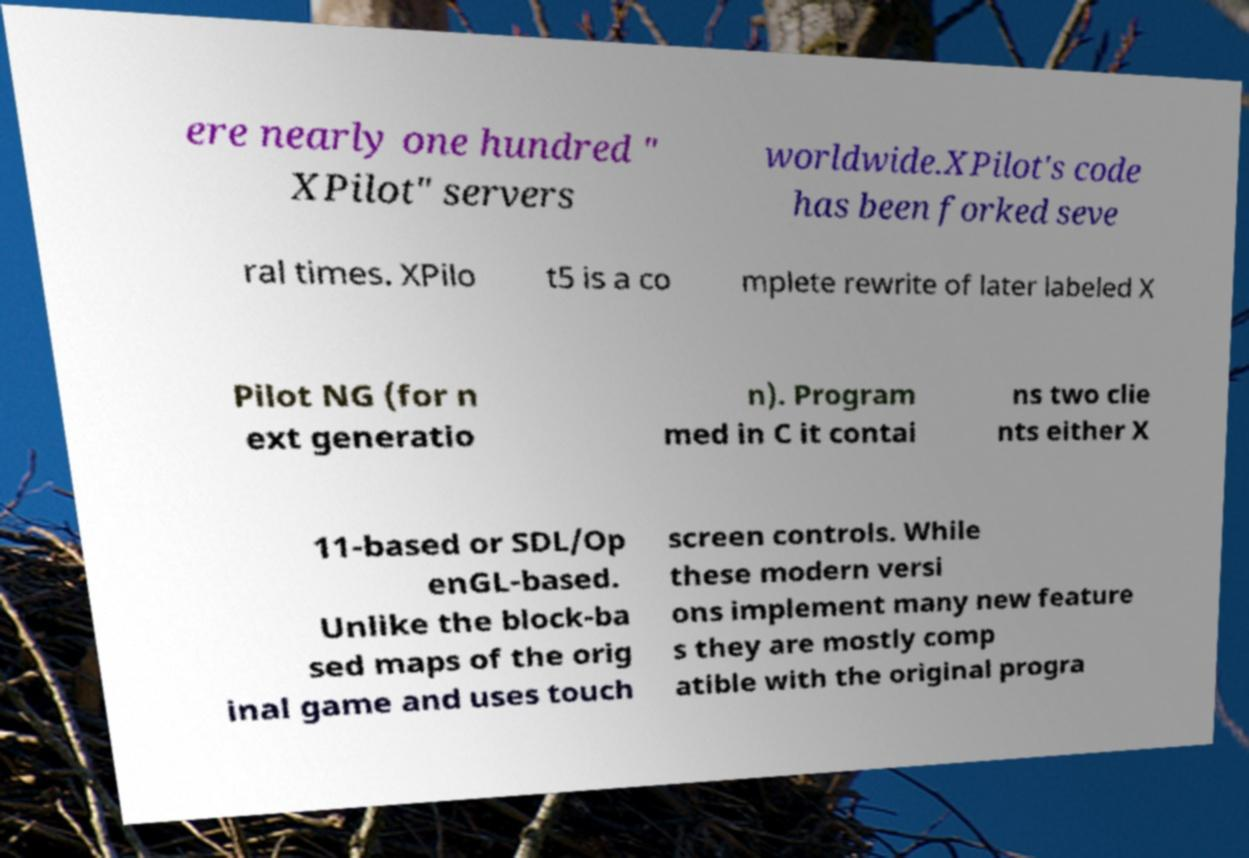Could you extract and type out the text from this image? ere nearly one hundred " XPilot" servers worldwide.XPilot's code has been forked seve ral times. XPilo t5 is a co mplete rewrite of later labeled X Pilot NG (for n ext generatio n). Program med in C it contai ns two clie nts either X 11-based or SDL/Op enGL-based. Unlike the block-ba sed maps of the orig inal game and uses touch screen controls. While these modern versi ons implement many new feature s they are mostly comp atible with the original progra 